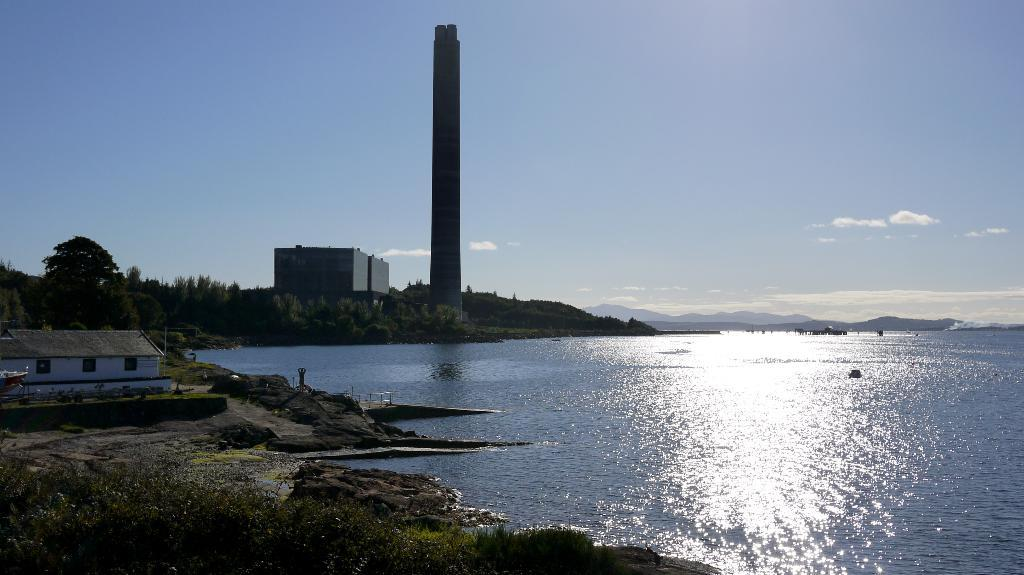What can be seen in the sky in the background of the image? There are clouds in the sky in the background of the image. What type of structures are present in the image? There is a building, a house, and a tower in the image. What natural features can be seen in the image? There are hills in the image. What type of vegetation is present in the image? There are plants in the image. What architectural feature is common to both the building and the house? There are windows in the image. What else can be seen in the image besides the structures and natural features? There are objects in the image. Is there any water visible in the image? Yes, there is water visible in the image. What type of circle is present in the image? There is no circle present in the image. How does the division of the objects in the image affect their taste? The taste of the objects in the image is not mentioned, and there is no division mentioned that would affect their taste. 